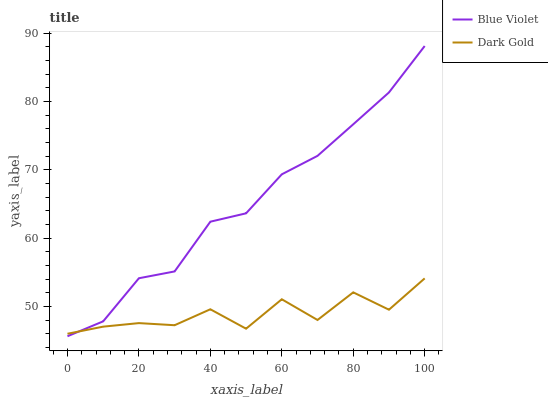Does Dark Gold have the minimum area under the curve?
Answer yes or no. Yes. Does Blue Violet have the maximum area under the curve?
Answer yes or no. Yes. Does Dark Gold have the maximum area under the curve?
Answer yes or no. No. Is Blue Violet the smoothest?
Answer yes or no. Yes. Is Dark Gold the roughest?
Answer yes or no. Yes. Is Dark Gold the smoothest?
Answer yes or no. No. Does Blue Violet have the lowest value?
Answer yes or no. Yes. Does Dark Gold have the lowest value?
Answer yes or no. No. Does Blue Violet have the highest value?
Answer yes or no. Yes. Does Dark Gold have the highest value?
Answer yes or no. No. Does Dark Gold intersect Blue Violet?
Answer yes or no. Yes. Is Dark Gold less than Blue Violet?
Answer yes or no. No. Is Dark Gold greater than Blue Violet?
Answer yes or no. No. 